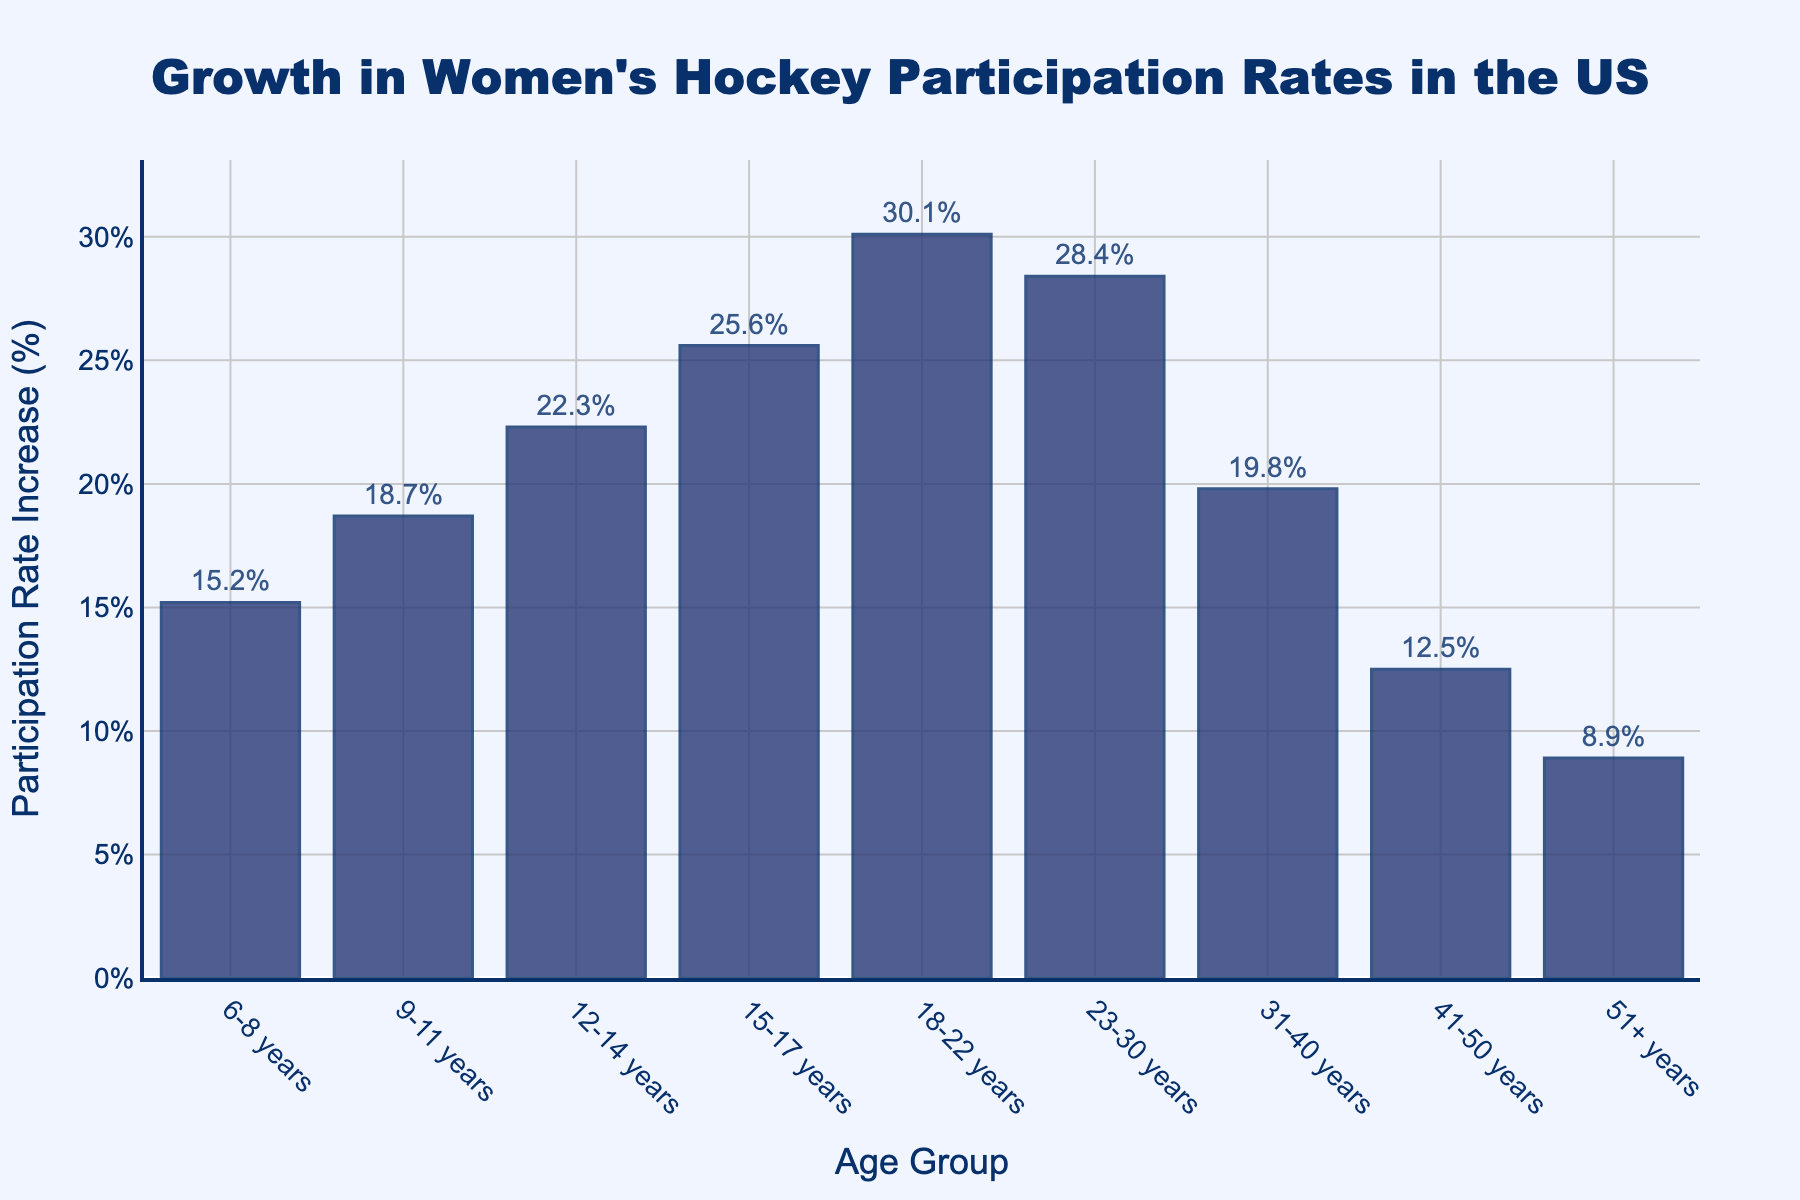What's the age group with the highest participation rate increase? The bar chart shows different age groups with varying heights. The tallest bar represents the age group with the highest increase in participation rates. The bar for the 18-22 years age group is the highest.
Answer: 18-22 years How much more did the 15-17 years age group increase compared to the 6-8 years age group? The participation rate increase for the 15-17 years age group is 25.6%, and for the 6-8 years age group, it is 15.2%. Subtract the values: 25.6% - 15.2% = 10.4%.
Answer: 10.4% Which age groups have a participation rate increase greater than 20%? Look at the bars whose heights represent more than 20%. The age groups 12-14 years, 15-17 years, 18-22 years, and 23-30 years show an increase greater than 20%.
Answer: 12-14 years, 15-17 years, 18-22 years, 23-30 years What's the total participation rate increase for all age groups combined? Sum up all the participation rates for each age group: 15.2% + 18.7% + 22.3% + 25.6% + 30.1% + 28.4% + 19.8% + 12.5% + 8.9% = 181.5%.
Answer: 181.5% What is the median participation rate increase among all age groups? Organize the participation rate increases in ascending order: 8.9%, 12.5%, 15.2%, 18.7%, 19.8%, 22.3%, 25.6%, 28.4%, 30.1%. The middle value in this sorted list is the 19.8%, which is positioned as the fifth value.
Answer: 19.8% How does the participation rate increase for 23-30 years compare with 31-40 years? The bar for the 23-30 years age group shows a 28.4% increase, and the bar for the 31-40 years age group shows a 19.8% increase. To compare, 28.4% is higher than 19.8%.
Answer: 23-30 years > 31-40 years What's the difference in participation rate increase between the 41-50 years and 51+ years age groups? Find the participation rate increases for the 41-50 years (12.5%) and 51+ years (8.9%) age groups. Subtract the 51+ years increase from the 41-50 years increase: 12.5% - 8.9% = 3.6%.
Answer: 3.6% Which age group shows the least growth in participation rates? The shortest bar on the chart represents the age group with the least growth. The 51+ years age group, with a 8.9% increase, is the shortest bar.
Answer: 51+ years 